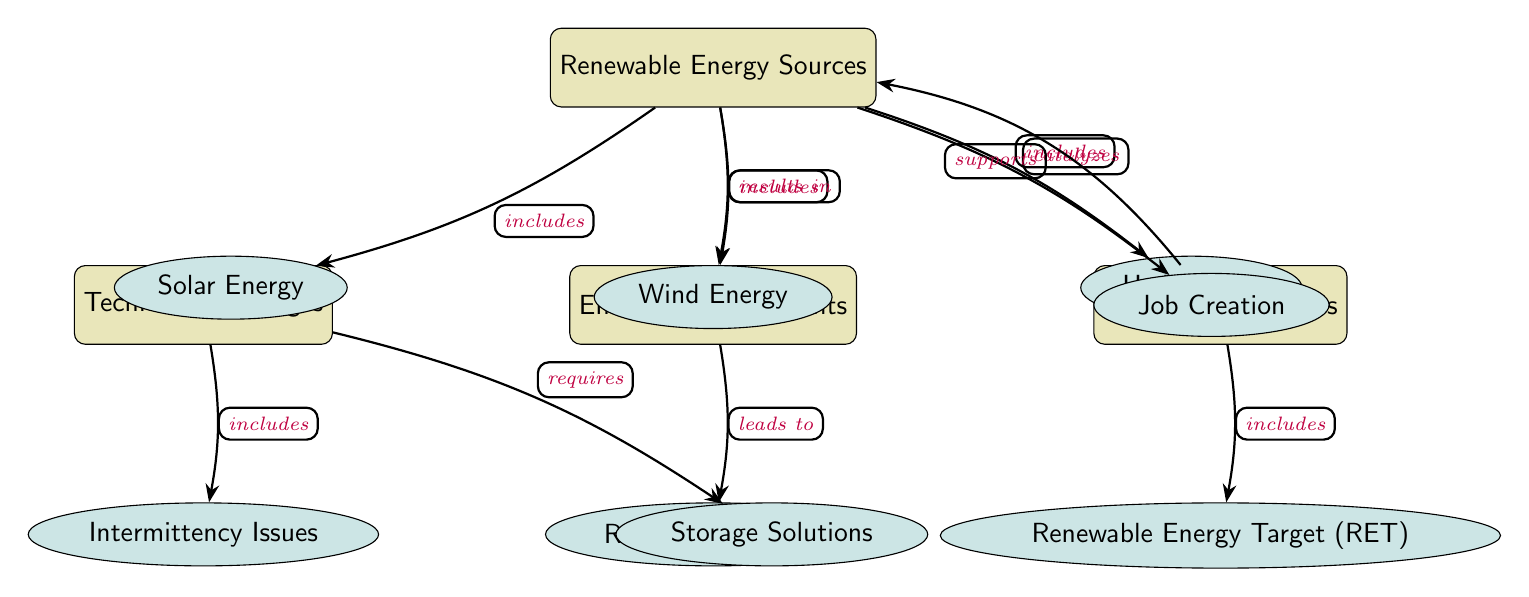What are the three renewable energy sources included in the diagram? The diagram contains three renewable energy sources indicated by distinct nodes: Solar Energy, Wind Energy, and Hydropower, all connected to the main node of Renewable Energy Sources.
Answer: Solar Energy, Wind Energy, Hydropower How many benefits are listed in the diagram? There are two benefits associated with renewable energy in the diagram: Reduced Emissions and Job Creation, as represented by sub-nodes branching from the Environmental Benefits node.
Answer: 2 What challenge is related to energy production in the diagram? The diagram identifies two technical challenges associated with renewable energy: Intermittency Issues and Storage Solutions, which are connected to the Technical Challenges node.
Answer: Intermittency Issues, Storage Solutions What policy supports renewable energy adoption according to the diagram? The diagram refers to the Renewable Energy Target (RET) as the government policy that supports the adoption of renewable energy, which is connected to the Government Policies node.
Answer: Renewable Energy Target (RET) How do renewable energy sources lead to job creation? The diagram shows that renewable energy sources catalyze job creation by being linked as a result from the Renewable Energy Sources node pointing towards the Job Creation node.
Answer: Job Creation What results from the reduction of emissions in the context of renewable energy? The diagram shows that Reduced Emissions lead to Environmental Benefits, opening up a connection from the Environmental Benefits node to this specific outcome.
Answer: Reduced Emissions Which nodes are directly connected to the Technical Challenges node? The Technical Challenges node has two directly connected sub-nodes: Intermittency Issues and Storage Solutions, indicating specific challenges associated with renewable energy technologies.
Answer: Intermittency Issues, Storage Solutions What type of energy sources does the diagram categorize? The diagram categorizes renewable energy sources into Solar Energy, Wind Energy, and Hydropower as types of Renewable Energy Sources, linked together at the main node of Renewable Energy Sources.
Answer: Renewable Energy Sources How many connections lead from Renewable Energy Sources to other nodes? There are four connections leading from the Renewable Energy Sources node: three to specific energy types and one to the Environmental Benefits node, demonstrating its contributions.
Answer: 4 